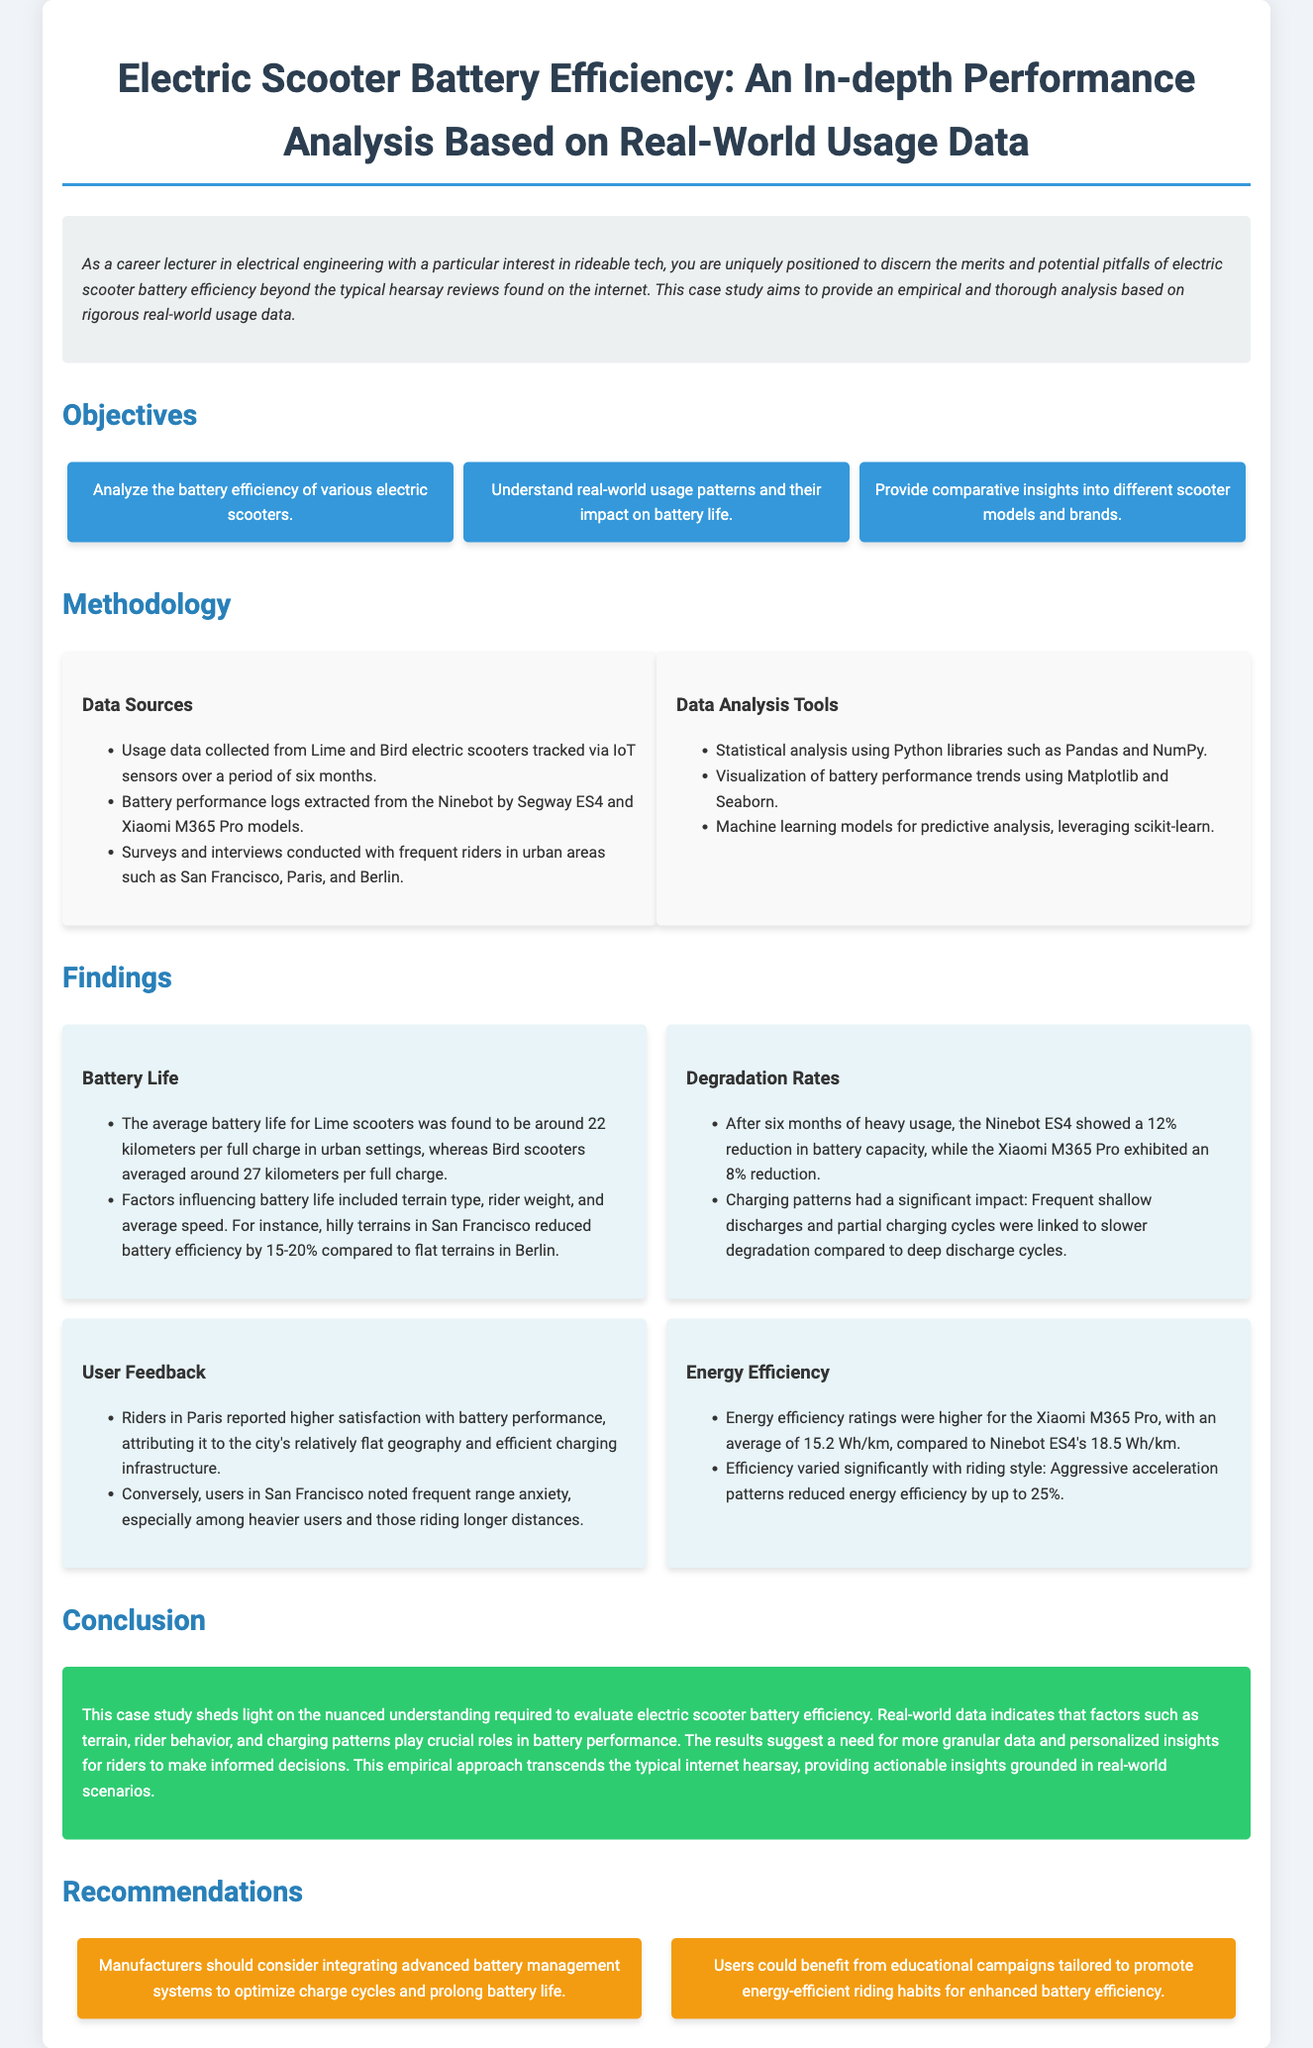What are the average battery lives for Lime and Bird scooters? The average battery life for Lime scooters is 22 kilometers, while Bird scooters average 27 kilometers per full charge.
Answer: 22 kilometers for Lime, 27 kilometers for Bird What percentage of battery reduction was noted for Ninebot ES4 after six months? After six months of heavy usage, the Ninebot ES4 showed a 12% reduction in battery capacity.
Answer: 12% What city reported higher rider satisfaction with battery performance? Riders in Paris reported higher satisfaction with battery performance.
Answer: Paris What is the energy efficiency rating for the Xiaomi M365 Pro? The Xiaomi M365 Pro has an average energy efficiency rating of 15.2 Wh/km.
Answer: 15.2 Wh/km What type of analysis was conducted using scikit-learn? Machine learning models for predictive analysis were leveraged using scikit-learn.
Answer: Predictive analysis How did aggressive acceleration patterns affect energy efficiency? Aggressive acceleration patterns reduced energy efficiency by up to 25%.
Answer: Up to 25% reduction What do the recommended educational campaigns aim to improve? The recommended educational campaigns aim to promote energy-efficient riding habits.
Answer: Energy-efficient riding habits 